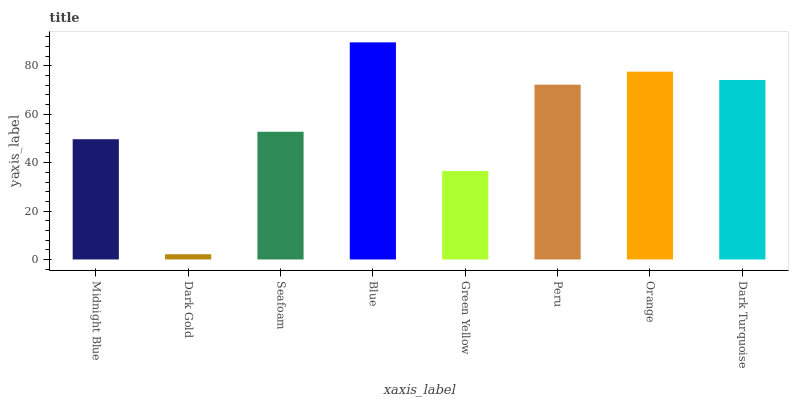Is Dark Gold the minimum?
Answer yes or no. Yes. Is Blue the maximum?
Answer yes or no. Yes. Is Seafoam the minimum?
Answer yes or no. No. Is Seafoam the maximum?
Answer yes or no. No. Is Seafoam greater than Dark Gold?
Answer yes or no. Yes. Is Dark Gold less than Seafoam?
Answer yes or no. Yes. Is Dark Gold greater than Seafoam?
Answer yes or no. No. Is Seafoam less than Dark Gold?
Answer yes or no. No. Is Peru the high median?
Answer yes or no. Yes. Is Seafoam the low median?
Answer yes or no. Yes. Is Orange the high median?
Answer yes or no. No. Is Orange the low median?
Answer yes or no. No. 